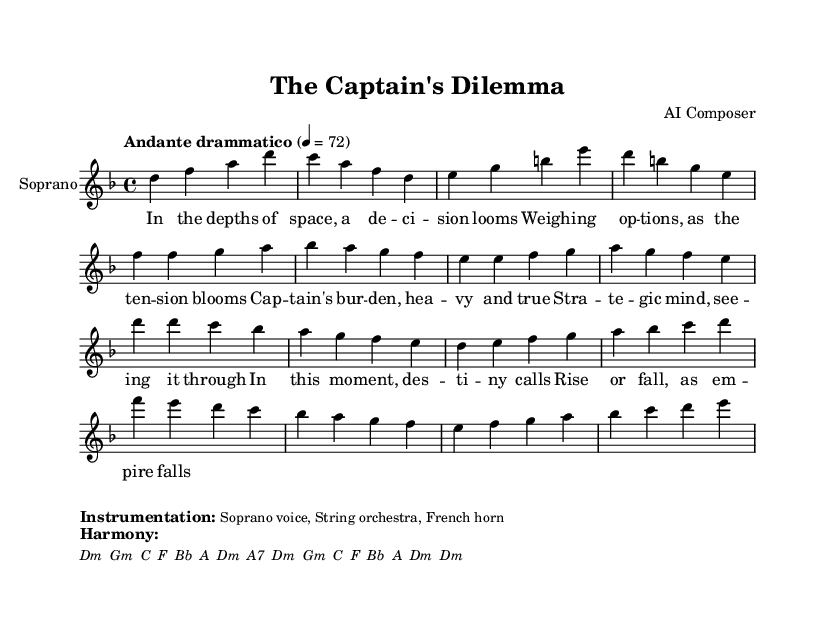What is the key signature of this music? The key signature is indicated at the beginning of the sheet music. It shows two flats, which corresponds to D minor.
Answer: D minor What is the time signature of this music? The time signature is shown as a fraction at the beginning of the score, which is 4 over 4. This means there are four beats in each measure.
Answer: 4/4 What is the tempo marking of this piece? The tempo marking appears on the first line and is indicated as "Andante drammatico," suggesting a moderately slow and dramatic pace.
Answer: Andante drammatico How many measures are there in the introduction? The introduction consists of four measures, as seen at the beginning before the verse starts.
Answer: 4 measures What is the primary vocal part in this score? The primary vocal part is labeled as "Soprano," which indicates that this is a soprano voice piece.
Answer: Soprano What instruments are specified for this piece? The instrumentation is indicated in the markup section at the bottom, naming a soprano voice, string orchestra, and French horn.
Answer: Soprano voice, String orchestra, French horn What is the theme addressed in the lyrics? The lyrics focus on strategic decision-making and leadership in a dramatic context, capturing the essence of a captain's burden in a moment of choice.
Answer: Strategic decision-making and leadership 